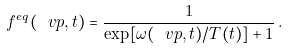<formula> <loc_0><loc_0><loc_500><loc_500>f ^ { e q } ( \ v p , t ) = \frac { 1 } { \exp [ \omega ( \ v p , t ) / T ( t ) ] + 1 } \, .</formula> 